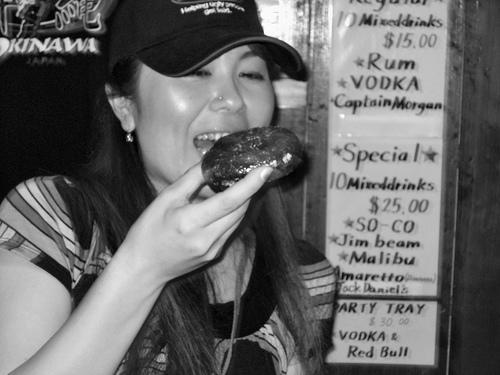How many donuts is the woman holding?
Give a very brief answer. 1. 